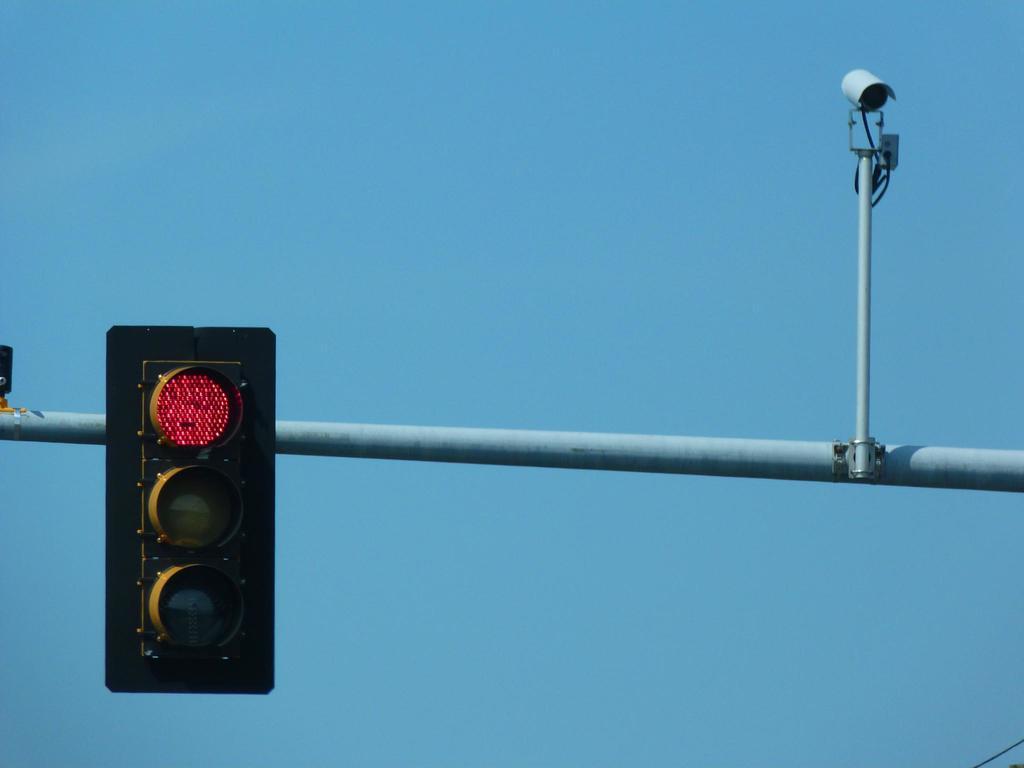Please provide a concise description of this image. In the center of the image a rod is there. To that road traffic lights and CC camera are there. In the background of the image sky is there. 